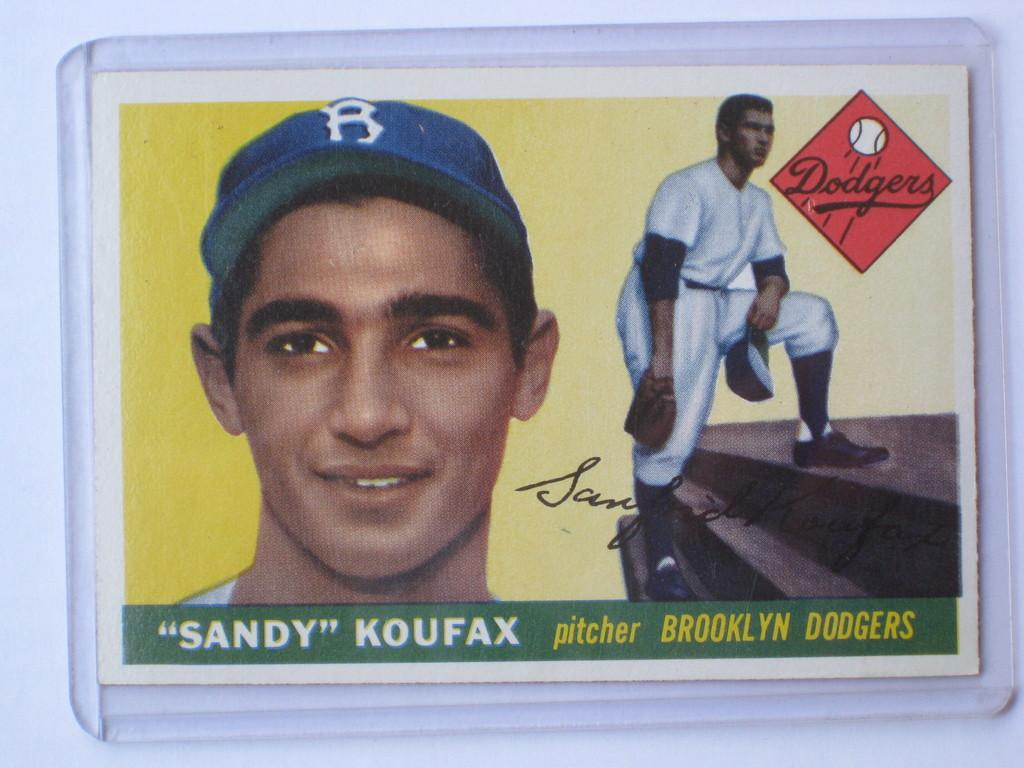What can be said about the nature of the image? The image is edited. What is the primary subject of the image? There are there any people in the image? Is there any text present in the image? Yes, there is text on the image. What can be seen in the background of the image? There is a wall in the background of the image. What type of brush is being used by the person in the image? There is no brush visible in the image, as it features persons and text on a wall. Can you tell me how many windows are present in the image? There are no windows visible in the image; it features persons, text, and a wall. 